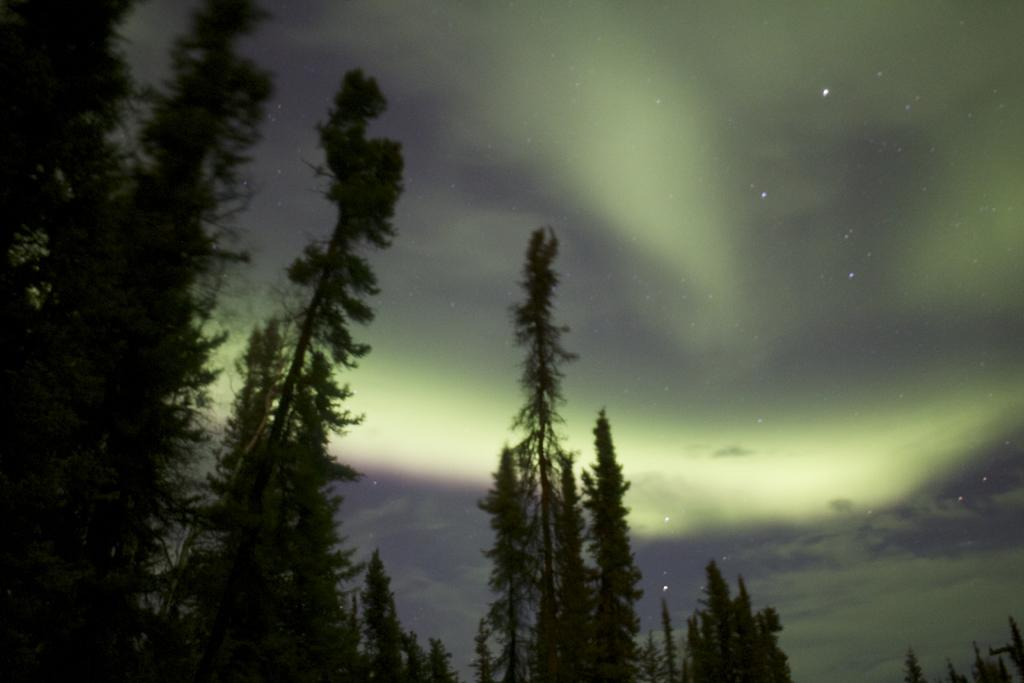What type of vegetation is visible in the image? There are trees in the image. What celestial objects can be seen in the image? Stars are visible in the image. What can be seen in the sky in the image? Clouds are present in the sky in the image. How many fingers can be seen pointing at the stars in the image? There are no fingers visible in the image, as it only features trees, stars, and clouds. Are there any cows present in the image? There are no cows present in the image; it only features trees, stars, and clouds. 